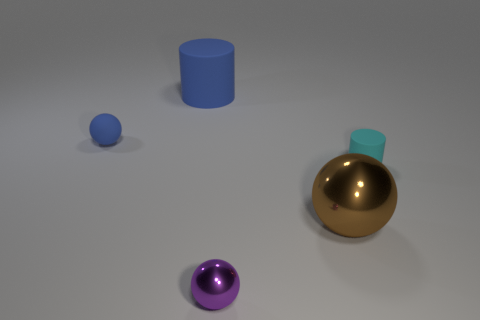What material is the tiny ball that is in front of the small matte object that is on the right side of the metal ball to the right of the tiny purple metal thing made of?
Provide a succinct answer. Metal. What is the material of the cyan cylinder?
Offer a very short reply. Rubber. What size is the blue rubber thing that is the same shape as the purple thing?
Your answer should be compact. Small. Does the large shiny object have the same color as the large rubber thing?
Offer a terse response. No. What number of other objects are the same material as the cyan thing?
Your answer should be compact. 2. Are there an equal number of purple metallic balls behind the large cylinder and gray blocks?
Make the answer very short. Yes. Do the metallic object that is on the right side of the purple sphere and the small cyan thing have the same size?
Keep it short and to the point. No. How many small purple metallic balls are on the left side of the brown shiny thing?
Offer a very short reply. 1. There is a tiny thing that is left of the cyan cylinder and behind the large brown object; what material is it?
Offer a very short reply. Rubber. What number of small objects are either brown shiny things or purple blocks?
Provide a succinct answer. 0. 